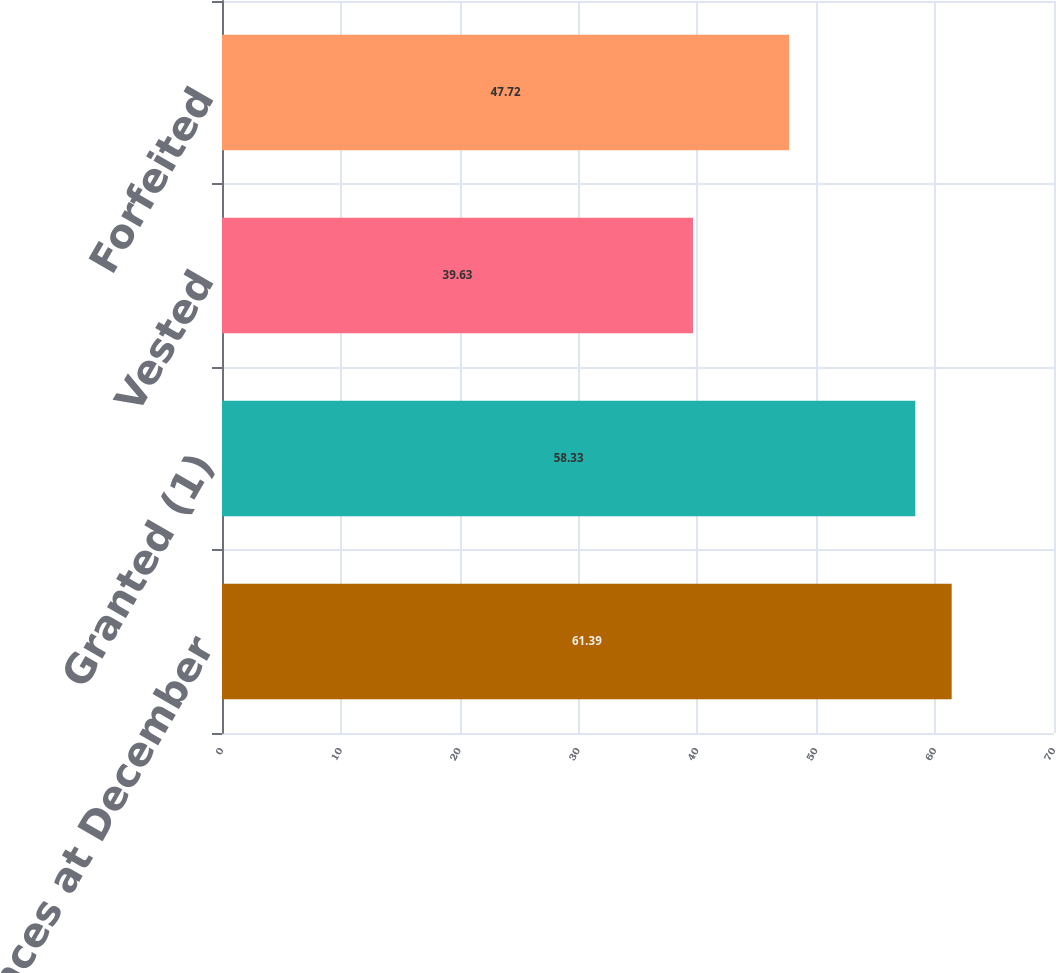<chart> <loc_0><loc_0><loc_500><loc_500><bar_chart><fcel>Unvested balances at December<fcel>Granted (1)<fcel>Vested<fcel>Forfeited<nl><fcel>61.39<fcel>58.33<fcel>39.63<fcel>47.72<nl></chart> 